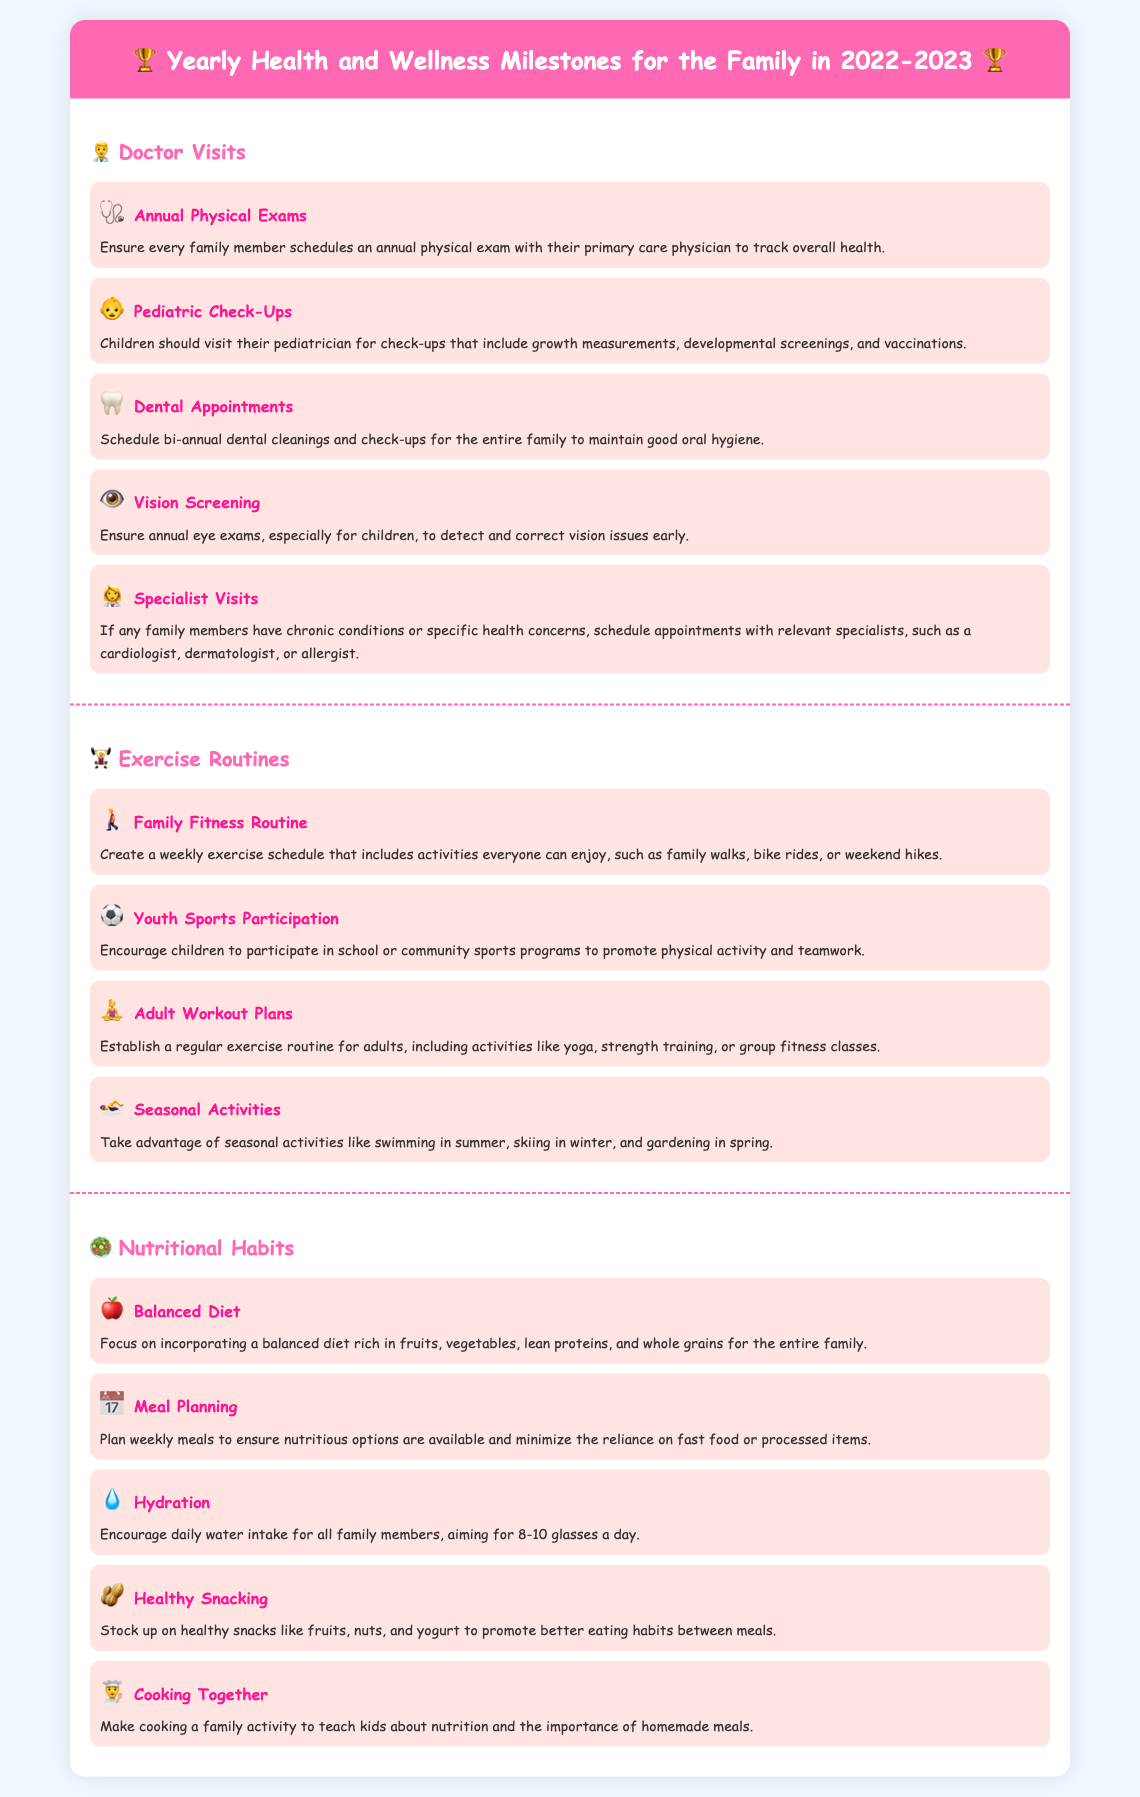What are the annual visits for children? Children should visit their pediatrician for check-ups that include growth measurements, developmental screenings, and vaccinations.
Answer: Pediatric Check-Ups How often should family members schedule dental appointments? Schedule bi-annual dental cleanings and check-ups for the entire family to maintain good oral hygiene.
Answer: Bi-annual What type of activities are included in the family fitness routine? Create a weekly exercise schedule that includes activities everyone can enjoy, such as family walks, bike rides, or weekend hikes.
Answer: Family walks, bike rides, or weekend hikes What nutritional habit encourages better eating between meals? Stock up on healthy snacks like fruits, nuts, and yogurt to promote better eating habits between meals.
Answer: Healthy Snacking How many glasses of water are recommended daily for family members? Encourage daily water intake for all family members, aiming for 8-10 glasses a day.
Answer: 8-10 glasses 